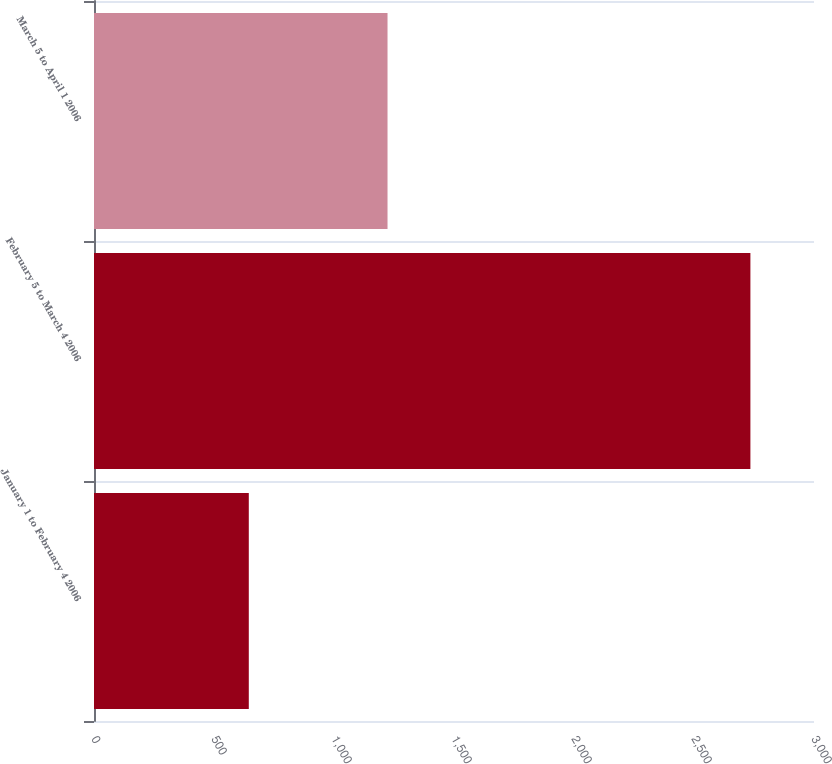Convert chart. <chart><loc_0><loc_0><loc_500><loc_500><bar_chart><fcel>January 1 to February 4 2006<fcel>February 5 to March 4 2006<fcel>March 5 to April 1 2006<nl><fcel>645<fcel>2735<fcel>1223<nl></chart> 